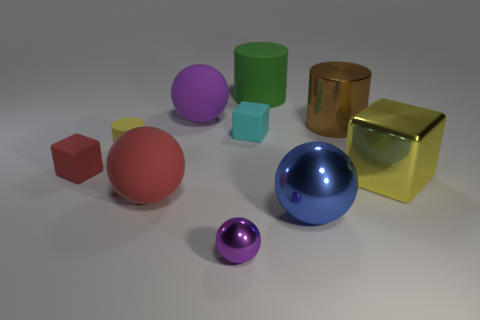There is a purple object right of the purple object that is behind the brown metallic cylinder; how many cylinders are on the right side of it?
Offer a very short reply. 2. Is the number of red rubber blocks behind the small red rubber cube the same as the number of large red objects?
Your response must be concise. No. What number of cubes are big purple matte things or shiny things?
Keep it short and to the point. 1. Does the large cube have the same color as the tiny cylinder?
Your answer should be very brief. Yes. Are there the same number of blue metal spheres that are to the left of the blue thing and purple metallic objects that are right of the tiny purple shiny sphere?
Ensure brevity in your answer.  Yes. What is the color of the metallic cube?
Offer a very short reply. Yellow. How many things are large objects behind the tiny red rubber block or big shiny cubes?
Ensure brevity in your answer.  4. There is a cylinder that is behind the metallic cylinder; is it the same size as the yellow thing that is behind the yellow shiny object?
Give a very brief answer. No. Is there anything else that has the same material as the small cyan thing?
Make the answer very short. Yes. What number of objects are either metal objects that are behind the large yellow shiny thing or large spheres that are on the left side of the blue ball?
Give a very brief answer. 3. 